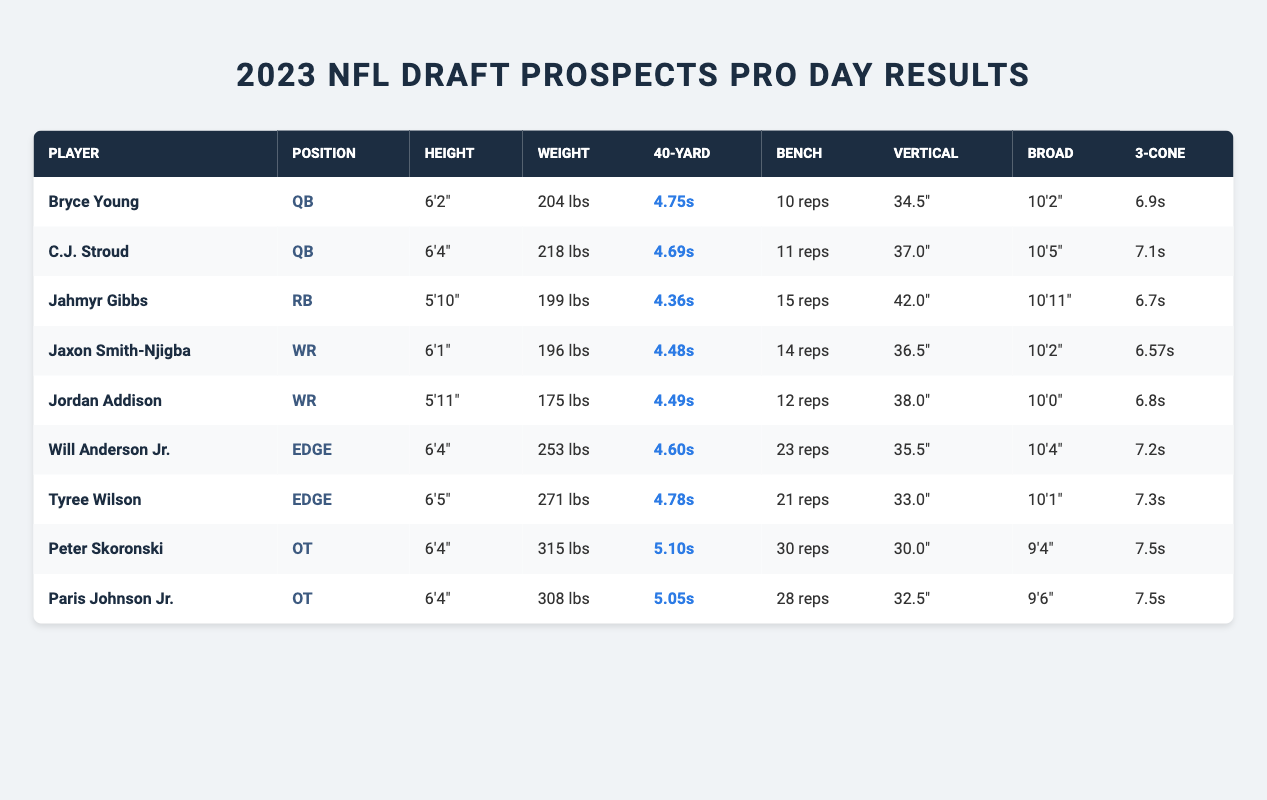What is the height of Jahmyr Gibbs? Looking at the table, the height of Jahmyr Gibbs is specified directly in his row under the "Height" column. He is listed as 5'10".
Answer: 5'10" Who has the fastest 40-yard dash time among the prospects? By comparing the "40-Yard" column for all players, Jahmyr Gibbs has the fastest time of 4.36 seconds, which is lower than the times of all other players.
Answer: Jahmyr Gibbs (4.36 seconds) How many players weigh over 250 pounds? Checking the "Weight" column, Will Anderson Jr. (253 lbs) and Tyree Wilson (271 lbs) are the only two players who weigh over 250 pounds.
Answer: 2 players What is the average bench press for the QB position? The bench press numbers for the QBs are 10 reps (Bryce Young) and 11 reps (C.J. Stroud). Adding them gives 21, and dividing by 2 gives an average of 10.5 reps.
Answer: 10.5 reps Is Jordan Addison taller than Jaxon Smith-Njigba? Comparing the heights listed for both players in the table, Jordan Addison is 5'11" and Jaxon Smith-Njigba is 6'1". Since 5'11" is less than 6'1", Jordan Addison is not taller.
Answer: No Who has the highest vertical jump among wide receivers? Looking at the "Vertical" column, Jaxon Smith-Njigba has a vertical jump of 36.5 inches, while Jordan Addison has 38.0 inches. Jordan Addison has the highest vertical jump among WRs.
Answer: Jordan Addison (38.0 inches) What is the total weight of all offensive tackle prospects? The weights for the two offensive tackles are Peter Skoronski (315 lbs) and Paris Johnson Jr. (308 lbs). Adding these gives a total of 623 lbs for both players combined.
Answer: 623 lbs Which player recorded the best broad jump? Reviewing the "Broad" column, Jahmyr Gibbs recorded a broad jump of 10'11", which is higher than all the other prospects' measurements.
Answer: Jahmyr Gibbs (10'11") Are there any players with a vertical jump of 35 inches or more? By examining the "Vertical" column, both Jahmyr Gibbs (42.0 inches) and C.J. Stroud (37.0 inches) have vertical jumps of 35 inches or more, confirming that there are players who meet this criterion.
Answer: Yes What is the difference in 40-yard dash time between the fastest and slowest players? The fastest 40-yard dash time is Jahmyr Gibbs at 4.36 seconds, and the slowest is Peter Skoronski at 5.10 seconds. The difference is 5.10 - 4.36 = 0.74 seconds.
Answer: 0.74 seconds Which position has the highest average vertical jump? The vertical jumps are: QBs (34.5, 37.0), RB (42.0), WRs (36.5, 38.0), and EDGE (35.5, 33.0). Average for each position is: QBs = 35.75, RB = 42.0, WRs = 37.25, EDGE = 34.25. The RB position has the highest average vertical jump at 42.0 inches.
Answer: RB (42.0 inches) 